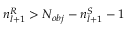<formula> <loc_0><loc_0><loc_500><loc_500>n _ { l + 1 } ^ { R } > N _ { o b j } - n _ { l + 1 } ^ { S } - 1</formula> 